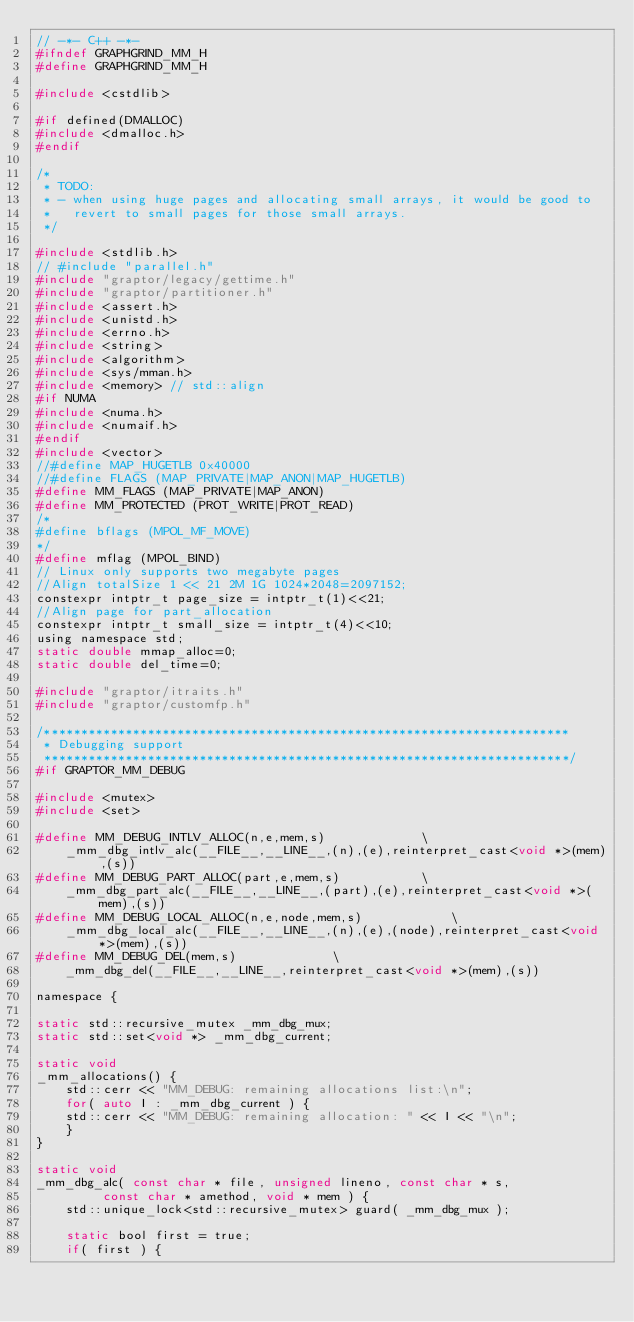<code> <loc_0><loc_0><loc_500><loc_500><_C_>// -*- C++ -*-
#ifndef GRAPHGRIND_MM_H
#define GRAPHGRIND_MM_H

#include <cstdlib>

#if defined(DMALLOC)
#include <dmalloc.h>
#endif

/*
 * TODO:
 * - when using huge pages and allocating small arrays, it would be good to
 *   revert to small pages for those small arrays.
 */

#include <stdlib.h>
// #include "parallel.h"
#include "graptor/legacy/gettime.h"
#include "graptor/partitioner.h"
#include <assert.h>
#include <unistd.h>
#include <errno.h>
#include <string>
#include <algorithm>
#include <sys/mman.h>
#include <memory> // std::align
#if NUMA
#include <numa.h>
#include <numaif.h>
#endif
#include <vector>
//#define MAP_HUGETLB 0x40000
//#define FLAGS (MAP_PRIVATE|MAP_ANON|MAP_HUGETLB)
#define MM_FLAGS (MAP_PRIVATE|MAP_ANON)
#define MM_PROTECTED (PROT_WRITE|PROT_READ)
/*
#define bflags (MPOL_MF_MOVE)
*/
#define mflag (MPOL_BIND)
// Linux only supports two megabyte pages
//Align totalSize 1 << 21 2M 1G 1024*2048=2097152;
constexpr intptr_t page_size = intptr_t(1)<<21;
//Align page for part_allocation
constexpr intptr_t small_size = intptr_t(4)<<10;
using namespace std;
static double mmap_alloc=0;
static double del_time=0;

#include "graptor/itraits.h"
#include "graptor/customfp.h"

/***********************************************************************
 * Debugging support
 ***********************************************************************/
#if GRAPTOR_MM_DEBUG

#include <mutex>
#include <set>

#define MM_DEBUG_INTLV_ALLOC(n,e,mem,s)				\
    _mm_dbg_intlv_alc(__FILE__,__LINE__,(n),(e),reinterpret_cast<void *>(mem),(s))
#define MM_DEBUG_PART_ALLOC(part,e,mem,s)			\
    _mm_dbg_part_alc(__FILE__,__LINE__,(part),(e),reinterpret_cast<void *>(mem),(s))
#define MM_DEBUG_LOCAL_ALLOC(n,e,node,mem,s)			\
    _mm_dbg_local_alc(__FILE__,__LINE__,(n),(e),(node),reinterpret_cast<void *>(mem),(s))
#define MM_DEBUG_DEL(mem,s) 	 	 	\
    _mm_dbg_del(__FILE__,__LINE__,reinterpret_cast<void *>(mem),(s))

namespace {

static std::recursive_mutex _mm_dbg_mux;
static std::set<void *> _mm_dbg_current;

static void
_mm_allocations() {
    std::cerr << "MM_DEBUG: remaining allocations list:\n";
    for( auto I : _mm_dbg_current ) {
	std::cerr << "MM_DEBUG: remaining allocation: " << I << "\n";
    }
}

static void
_mm_dbg_alc( const char * file, unsigned lineno, const char * s,
	     const char * amethod, void * mem ) {
    std::unique_lock<std::recursive_mutex> guard( _mm_dbg_mux );

    static bool first = true;
    if( first ) {</code> 